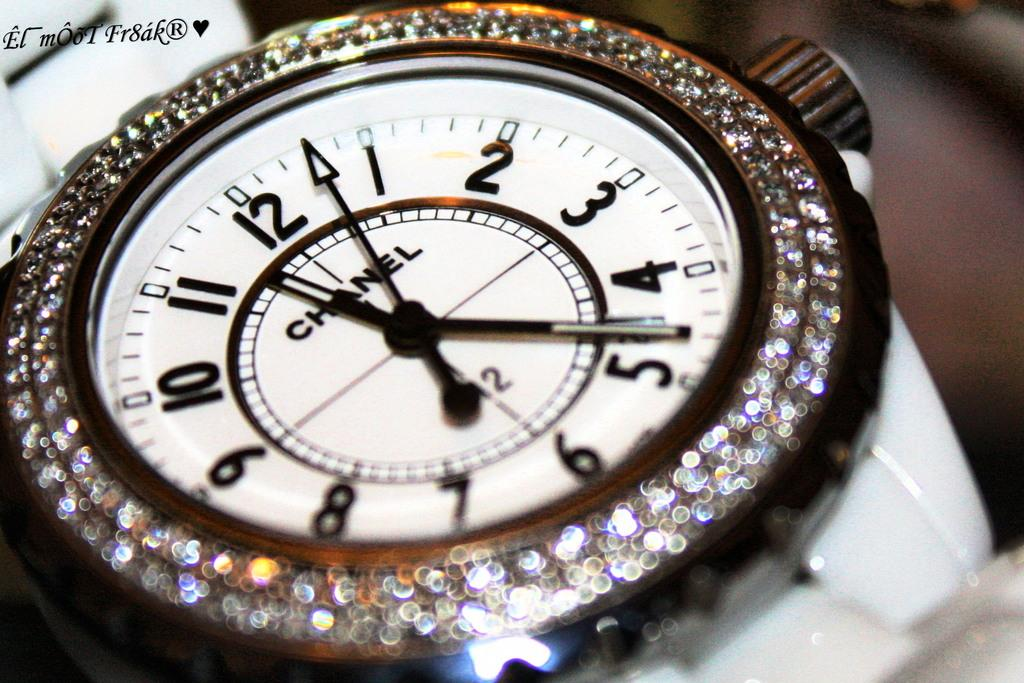<image>
Give a short and clear explanation of the subsequent image. The watch with the diamonds on the outer edge is designed by Chanel. 